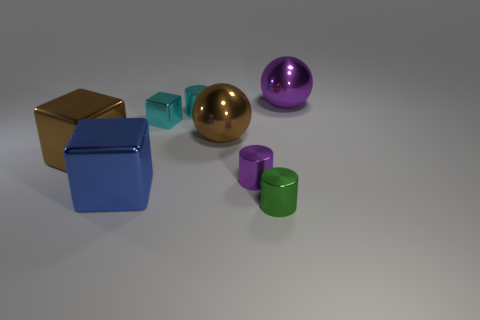Is the size of the sphere left of the purple ball the same as the green object on the right side of the big blue cube?
Offer a terse response. No. Are there fewer tiny objects on the left side of the large brown block than big brown balls?
Your answer should be very brief. Yes. Is the number of small cyan metallic cylinders greater than the number of tiny cyan shiny objects?
Give a very brief answer. No. Are there any big brown metal spheres in front of the brown metal object left of the metallic sphere that is to the left of the purple ball?
Provide a short and direct response. No. How many other things are there of the same size as the purple ball?
Your answer should be compact. 3. There is a brown cube; are there any large blocks to the right of it?
Give a very brief answer. Yes. Is the color of the small shiny block the same as the shiny cylinder behind the big brown metallic block?
Make the answer very short. Yes. There is a cylinder behind the sphere that is on the left side of the big sphere that is right of the tiny purple object; what is its color?
Offer a terse response. Cyan. Is there a small blue thing that has the same shape as the green object?
Give a very brief answer. No. There is another shiny block that is the same size as the blue metallic block; what is its color?
Ensure brevity in your answer.  Brown. 